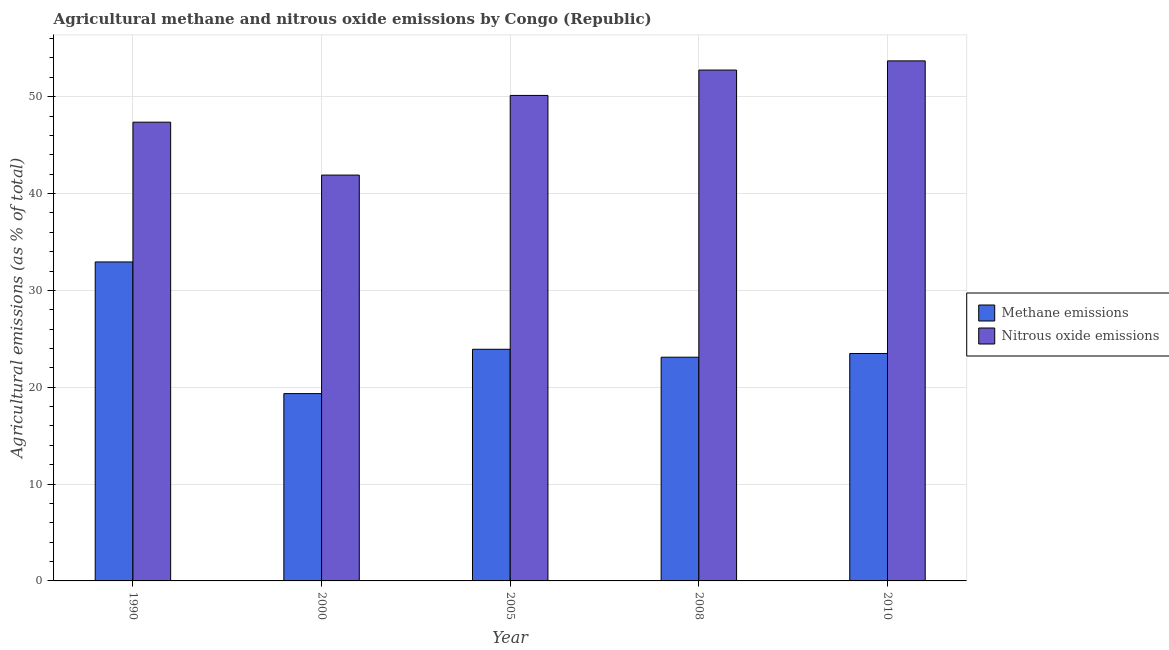How many different coloured bars are there?
Make the answer very short. 2. How many groups of bars are there?
Provide a succinct answer. 5. Are the number of bars per tick equal to the number of legend labels?
Provide a short and direct response. Yes. Are the number of bars on each tick of the X-axis equal?
Your answer should be compact. Yes. How many bars are there on the 4th tick from the left?
Give a very brief answer. 2. What is the label of the 5th group of bars from the left?
Your answer should be very brief. 2010. What is the amount of methane emissions in 2010?
Offer a terse response. 23.48. Across all years, what is the maximum amount of methane emissions?
Offer a terse response. 32.93. Across all years, what is the minimum amount of nitrous oxide emissions?
Give a very brief answer. 41.9. In which year was the amount of methane emissions maximum?
Provide a succinct answer. 1990. What is the total amount of methane emissions in the graph?
Offer a terse response. 122.78. What is the difference between the amount of methane emissions in 2000 and that in 2008?
Provide a short and direct response. -3.76. What is the difference between the amount of methane emissions in 2005 and the amount of nitrous oxide emissions in 2008?
Your answer should be compact. 0.82. What is the average amount of methane emissions per year?
Keep it short and to the point. 24.56. In the year 2000, what is the difference between the amount of methane emissions and amount of nitrous oxide emissions?
Make the answer very short. 0. What is the ratio of the amount of nitrous oxide emissions in 1990 to that in 2005?
Give a very brief answer. 0.94. Is the amount of methane emissions in 1990 less than that in 2010?
Provide a short and direct response. No. What is the difference between the highest and the second highest amount of methane emissions?
Ensure brevity in your answer.  9.02. What is the difference between the highest and the lowest amount of methane emissions?
Offer a terse response. 13.59. In how many years, is the amount of methane emissions greater than the average amount of methane emissions taken over all years?
Your response must be concise. 1. What does the 1st bar from the left in 2010 represents?
Keep it short and to the point. Methane emissions. What does the 2nd bar from the right in 1990 represents?
Your response must be concise. Methane emissions. Are all the bars in the graph horizontal?
Provide a succinct answer. No. How many years are there in the graph?
Give a very brief answer. 5. What is the difference between two consecutive major ticks on the Y-axis?
Offer a very short reply. 10. Does the graph contain any zero values?
Make the answer very short. No. Does the graph contain grids?
Offer a terse response. Yes. How many legend labels are there?
Provide a succinct answer. 2. How are the legend labels stacked?
Your answer should be compact. Vertical. What is the title of the graph?
Offer a very short reply. Agricultural methane and nitrous oxide emissions by Congo (Republic). What is the label or title of the X-axis?
Provide a succinct answer. Year. What is the label or title of the Y-axis?
Your answer should be compact. Agricultural emissions (as % of total). What is the Agricultural emissions (as % of total) in Methane emissions in 1990?
Offer a terse response. 32.93. What is the Agricultural emissions (as % of total) in Nitrous oxide emissions in 1990?
Your answer should be compact. 47.37. What is the Agricultural emissions (as % of total) in Methane emissions in 2000?
Provide a short and direct response. 19.34. What is the Agricultural emissions (as % of total) of Nitrous oxide emissions in 2000?
Offer a terse response. 41.9. What is the Agricultural emissions (as % of total) of Methane emissions in 2005?
Provide a succinct answer. 23.92. What is the Agricultural emissions (as % of total) in Nitrous oxide emissions in 2005?
Your answer should be very brief. 50.13. What is the Agricultural emissions (as % of total) in Methane emissions in 2008?
Give a very brief answer. 23.1. What is the Agricultural emissions (as % of total) in Nitrous oxide emissions in 2008?
Ensure brevity in your answer.  52.75. What is the Agricultural emissions (as % of total) of Methane emissions in 2010?
Give a very brief answer. 23.48. What is the Agricultural emissions (as % of total) in Nitrous oxide emissions in 2010?
Provide a succinct answer. 53.7. Across all years, what is the maximum Agricultural emissions (as % of total) in Methane emissions?
Your answer should be very brief. 32.93. Across all years, what is the maximum Agricultural emissions (as % of total) of Nitrous oxide emissions?
Offer a very short reply. 53.7. Across all years, what is the minimum Agricultural emissions (as % of total) in Methane emissions?
Ensure brevity in your answer.  19.34. Across all years, what is the minimum Agricultural emissions (as % of total) of Nitrous oxide emissions?
Ensure brevity in your answer.  41.9. What is the total Agricultural emissions (as % of total) in Methane emissions in the graph?
Keep it short and to the point. 122.78. What is the total Agricultural emissions (as % of total) in Nitrous oxide emissions in the graph?
Make the answer very short. 245.85. What is the difference between the Agricultural emissions (as % of total) of Methane emissions in 1990 and that in 2000?
Ensure brevity in your answer.  13.59. What is the difference between the Agricultural emissions (as % of total) of Nitrous oxide emissions in 1990 and that in 2000?
Your response must be concise. 5.46. What is the difference between the Agricultural emissions (as % of total) in Methane emissions in 1990 and that in 2005?
Offer a terse response. 9.02. What is the difference between the Agricultural emissions (as % of total) of Nitrous oxide emissions in 1990 and that in 2005?
Your response must be concise. -2.76. What is the difference between the Agricultural emissions (as % of total) in Methane emissions in 1990 and that in 2008?
Ensure brevity in your answer.  9.84. What is the difference between the Agricultural emissions (as % of total) of Nitrous oxide emissions in 1990 and that in 2008?
Provide a succinct answer. -5.38. What is the difference between the Agricultural emissions (as % of total) in Methane emissions in 1990 and that in 2010?
Offer a very short reply. 9.45. What is the difference between the Agricultural emissions (as % of total) in Nitrous oxide emissions in 1990 and that in 2010?
Ensure brevity in your answer.  -6.33. What is the difference between the Agricultural emissions (as % of total) in Methane emissions in 2000 and that in 2005?
Offer a very short reply. -4.58. What is the difference between the Agricultural emissions (as % of total) in Nitrous oxide emissions in 2000 and that in 2005?
Offer a terse response. -8.23. What is the difference between the Agricultural emissions (as % of total) of Methane emissions in 2000 and that in 2008?
Provide a succinct answer. -3.76. What is the difference between the Agricultural emissions (as % of total) of Nitrous oxide emissions in 2000 and that in 2008?
Offer a terse response. -10.84. What is the difference between the Agricultural emissions (as % of total) in Methane emissions in 2000 and that in 2010?
Make the answer very short. -4.14. What is the difference between the Agricultural emissions (as % of total) in Nitrous oxide emissions in 2000 and that in 2010?
Make the answer very short. -11.79. What is the difference between the Agricultural emissions (as % of total) of Methane emissions in 2005 and that in 2008?
Keep it short and to the point. 0.82. What is the difference between the Agricultural emissions (as % of total) of Nitrous oxide emissions in 2005 and that in 2008?
Your response must be concise. -2.62. What is the difference between the Agricultural emissions (as % of total) of Methane emissions in 2005 and that in 2010?
Your answer should be compact. 0.43. What is the difference between the Agricultural emissions (as % of total) of Nitrous oxide emissions in 2005 and that in 2010?
Your answer should be compact. -3.57. What is the difference between the Agricultural emissions (as % of total) in Methane emissions in 2008 and that in 2010?
Ensure brevity in your answer.  -0.38. What is the difference between the Agricultural emissions (as % of total) in Nitrous oxide emissions in 2008 and that in 2010?
Provide a short and direct response. -0.95. What is the difference between the Agricultural emissions (as % of total) of Methane emissions in 1990 and the Agricultural emissions (as % of total) of Nitrous oxide emissions in 2000?
Make the answer very short. -8.97. What is the difference between the Agricultural emissions (as % of total) in Methane emissions in 1990 and the Agricultural emissions (as % of total) in Nitrous oxide emissions in 2005?
Make the answer very short. -17.19. What is the difference between the Agricultural emissions (as % of total) in Methane emissions in 1990 and the Agricultural emissions (as % of total) in Nitrous oxide emissions in 2008?
Provide a succinct answer. -19.81. What is the difference between the Agricultural emissions (as % of total) of Methane emissions in 1990 and the Agricultural emissions (as % of total) of Nitrous oxide emissions in 2010?
Your answer should be compact. -20.76. What is the difference between the Agricultural emissions (as % of total) of Methane emissions in 2000 and the Agricultural emissions (as % of total) of Nitrous oxide emissions in 2005?
Provide a short and direct response. -30.79. What is the difference between the Agricultural emissions (as % of total) of Methane emissions in 2000 and the Agricultural emissions (as % of total) of Nitrous oxide emissions in 2008?
Provide a short and direct response. -33.41. What is the difference between the Agricultural emissions (as % of total) of Methane emissions in 2000 and the Agricultural emissions (as % of total) of Nitrous oxide emissions in 2010?
Your answer should be compact. -34.35. What is the difference between the Agricultural emissions (as % of total) in Methane emissions in 2005 and the Agricultural emissions (as % of total) in Nitrous oxide emissions in 2008?
Offer a terse response. -28.83. What is the difference between the Agricultural emissions (as % of total) of Methane emissions in 2005 and the Agricultural emissions (as % of total) of Nitrous oxide emissions in 2010?
Provide a short and direct response. -29.78. What is the difference between the Agricultural emissions (as % of total) in Methane emissions in 2008 and the Agricultural emissions (as % of total) in Nitrous oxide emissions in 2010?
Give a very brief answer. -30.6. What is the average Agricultural emissions (as % of total) of Methane emissions per year?
Your response must be concise. 24.56. What is the average Agricultural emissions (as % of total) in Nitrous oxide emissions per year?
Provide a succinct answer. 49.17. In the year 1990, what is the difference between the Agricultural emissions (as % of total) in Methane emissions and Agricultural emissions (as % of total) in Nitrous oxide emissions?
Your answer should be very brief. -14.43. In the year 2000, what is the difference between the Agricultural emissions (as % of total) of Methane emissions and Agricultural emissions (as % of total) of Nitrous oxide emissions?
Provide a short and direct response. -22.56. In the year 2005, what is the difference between the Agricultural emissions (as % of total) in Methane emissions and Agricultural emissions (as % of total) in Nitrous oxide emissions?
Offer a terse response. -26.21. In the year 2008, what is the difference between the Agricultural emissions (as % of total) in Methane emissions and Agricultural emissions (as % of total) in Nitrous oxide emissions?
Offer a terse response. -29.65. In the year 2010, what is the difference between the Agricultural emissions (as % of total) in Methane emissions and Agricultural emissions (as % of total) in Nitrous oxide emissions?
Your response must be concise. -30.21. What is the ratio of the Agricultural emissions (as % of total) of Methane emissions in 1990 to that in 2000?
Give a very brief answer. 1.7. What is the ratio of the Agricultural emissions (as % of total) of Nitrous oxide emissions in 1990 to that in 2000?
Offer a very short reply. 1.13. What is the ratio of the Agricultural emissions (as % of total) in Methane emissions in 1990 to that in 2005?
Your answer should be compact. 1.38. What is the ratio of the Agricultural emissions (as % of total) of Nitrous oxide emissions in 1990 to that in 2005?
Ensure brevity in your answer.  0.94. What is the ratio of the Agricultural emissions (as % of total) of Methane emissions in 1990 to that in 2008?
Ensure brevity in your answer.  1.43. What is the ratio of the Agricultural emissions (as % of total) in Nitrous oxide emissions in 1990 to that in 2008?
Your answer should be compact. 0.9. What is the ratio of the Agricultural emissions (as % of total) of Methane emissions in 1990 to that in 2010?
Your response must be concise. 1.4. What is the ratio of the Agricultural emissions (as % of total) in Nitrous oxide emissions in 1990 to that in 2010?
Your answer should be compact. 0.88. What is the ratio of the Agricultural emissions (as % of total) in Methane emissions in 2000 to that in 2005?
Keep it short and to the point. 0.81. What is the ratio of the Agricultural emissions (as % of total) in Nitrous oxide emissions in 2000 to that in 2005?
Provide a short and direct response. 0.84. What is the ratio of the Agricultural emissions (as % of total) of Methane emissions in 2000 to that in 2008?
Offer a terse response. 0.84. What is the ratio of the Agricultural emissions (as % of total) in Nitrous oxide emissions in 2000 to that in 2008?
Offer a terse response. 0.79. What is the ratio of the Agricultural emissions (as % of total) of Methane emissions in 2000 to that in 2010?
Offer a very short reply. 0.82. What is the ratio of the Agricultural emissions (as % of total) in Nitrous oxide emissions in 2000 to that in 2010?
Make the answer very short. 0.78. What is the ratio of the Agricultural emissions (as % of total) of Methane emissions in 2005 to that in 2008?
Keep it short and to the point. 1.04. What is the ratio of the Agricultural emissions (as % of total) of Nitrous oxide emissions in 2005 to that in 2008?
Your answer should be compact. 0.95. What is the ratio of the Agricultural emissions (as % of total) of Methane emissions in 2005 to that in 2010?
Keep it short and to the point. 1.02. What is the ratio of the Agricultural emissions (as % of total) in Nitrous oxide emissions in 2005 to that in 2010?
Give a very brief answer. 0.93. What is the ratio of the Agricultural emissions (as % of total) in Methane emissions in 2008 to that in 2010?
Give a very brief answer. 0.98. What is the ratio of the Agricultural emissions (as % of total) of Nitrous oxide emissions in 2008 to that in 2010?
Your answer should be very brief. 0.98. What is the difference between the highest and the second highest Agricultural emissions (as % of total) of Methane emissions?
Offer a very short reply. 9.02. What is the difference between the highest and the second highest Agricultural emissions (as % of total) in Nitrous oxide emissions?
Give a very brief answer. 0.95. What is the difference between the highest and the lowest Agricultural emissions (as % of total) of Methane emissions?
Make the answer very short. 13.59. What is the difference between the highest and the lowest Agricultural emissions (as % of total) in Nitrous oxide emissions?
Your answer should be compact. 11.79. 